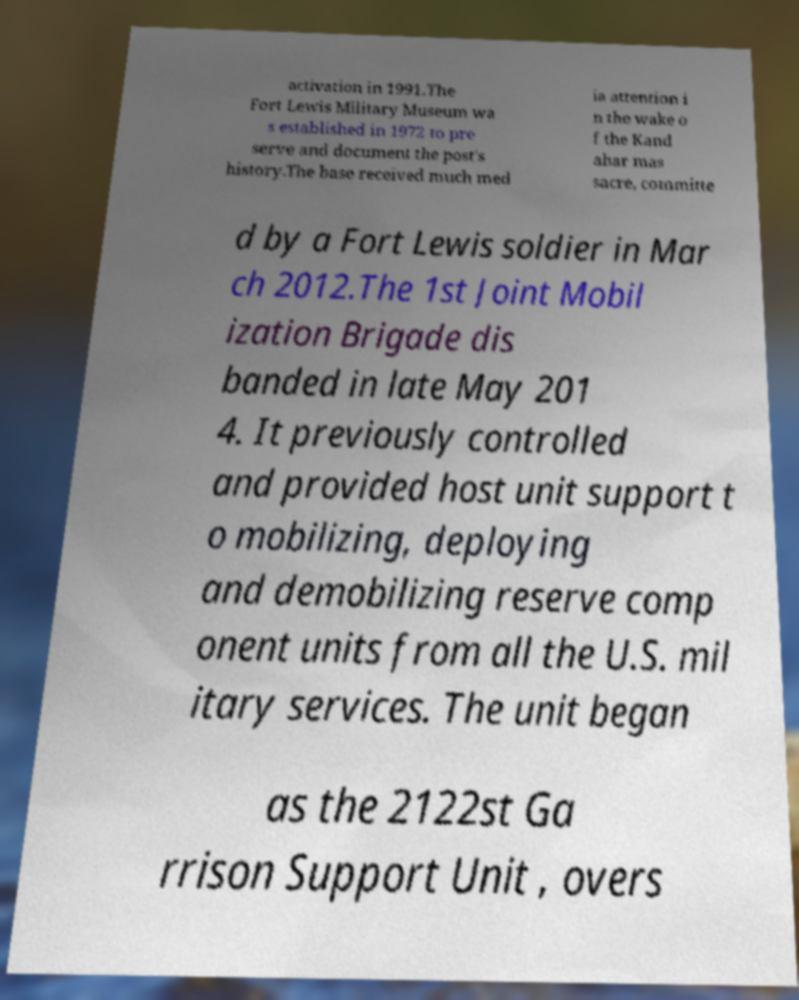What messages or text are displayed in this image? I need them in a readable, typed format. activation in 1991.The Fort Lewis Military Museum wa s established in 1972 to pre serve and document the post's history.The base received much med ia attention i n the wake o f the Kand ahar mas sacre, committe d by a Fort Lewis soldier in Mar ch 2012.The 1st Joint Mobil ization Brigade dis banded in late May 201 4. It previously controlled and provided host unit support t o mobilizing, deploying and demobilizing reserve comp onent units from all the U.S. mil itary services. The unit began as the 2122st Ga rrison Support Unit , overs 